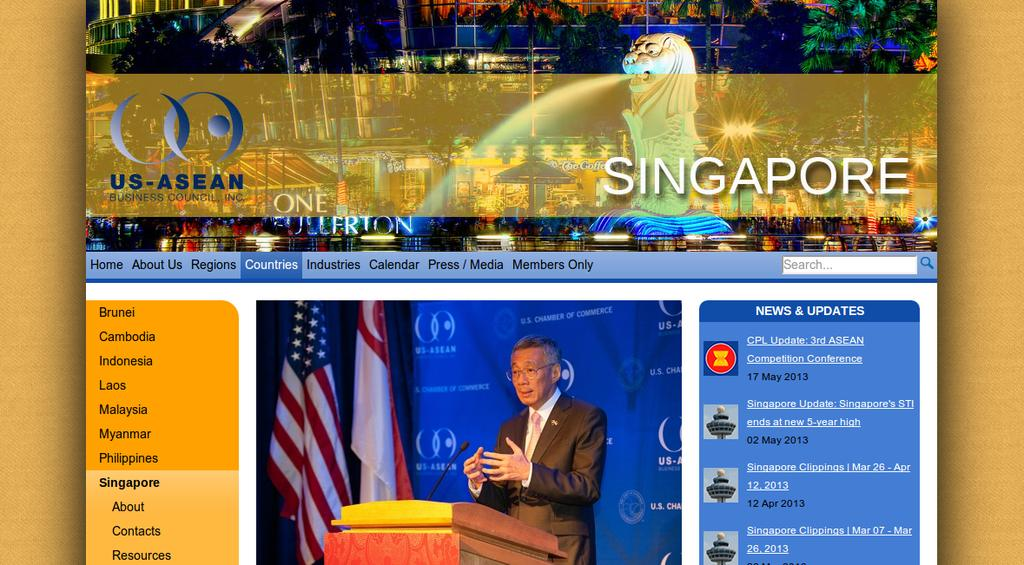Provide a one-sentence caption for the provided image. The top half of a poster advertising an event in Singapore. 